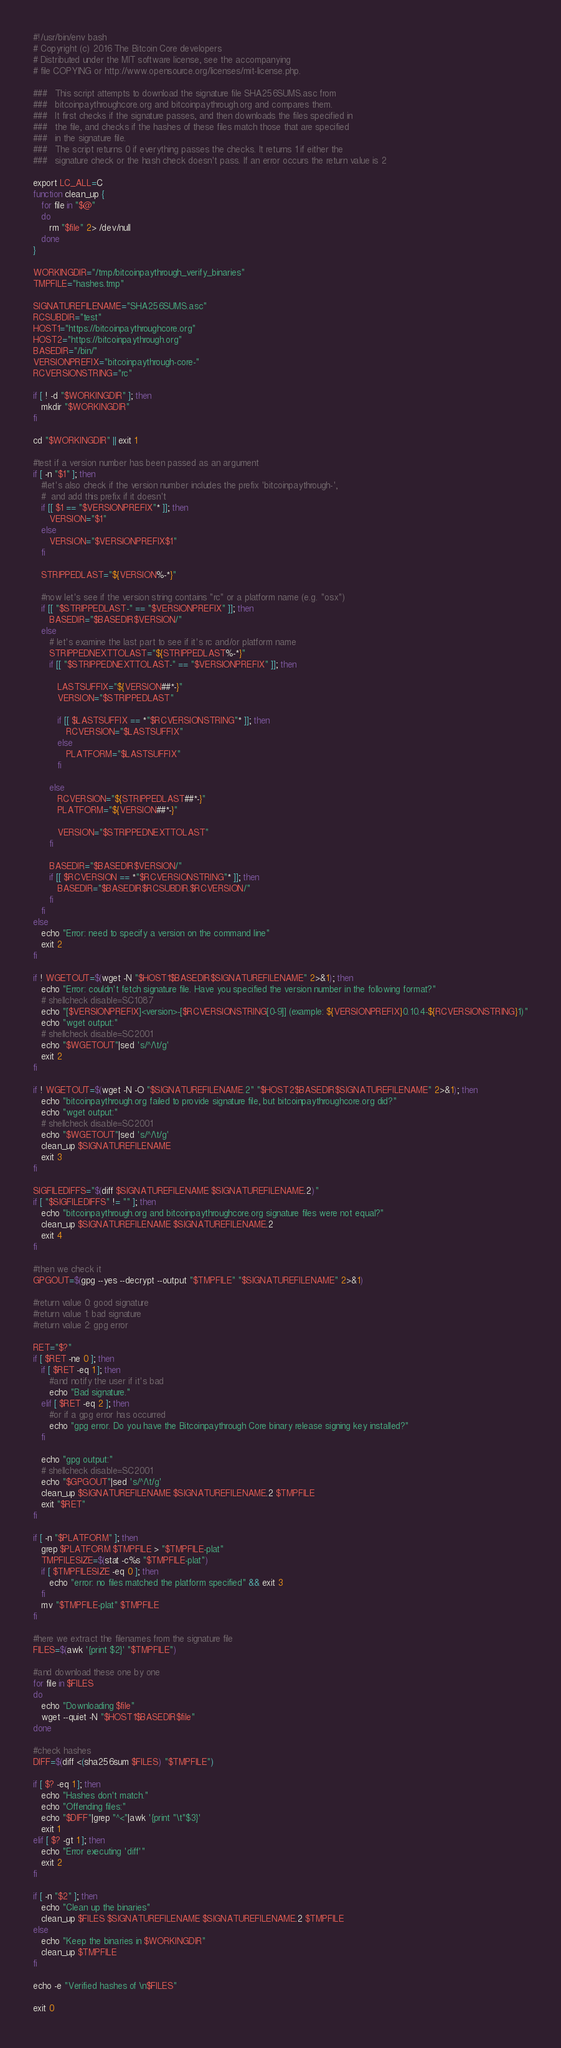<code> <loc_0><loc_0><loc_500><loc_500><_Bash_>#!/usr/bin/env bash
# Copyright (c) 2016 The Bitcoin Core developers
# Distributed under the MIT software license, see the accompanying
# file COPYING or http://www.opensource.org/licenses/mit-license.php.

###   This script attempts to download the signature file SHA256SUMS.asc from
###   bitcoinpaythroughcore.org and bitcoinpaythrough.org and compares them.
###   It first checks if the signature passes, and then downloads the files specified in
###   the file, and checks if the hashes of these files match those that are specified
###   in the signature file.
###   The script returns 0 if everything passes the checks. It returns 1 if either the
###   signature check or the hash check doesn't pass. If an error occurs the return value is 2

export LC_ALL=C
function clean_up {
   for file in "$@"
   do
      rm "$file" 2> /dev/null
   done
}

WORKINGDIR="/tmp/bitcoinpaythrough_verify_binaries"
TMPFILE="hashes.tmp"

SIGNATUREFILENAME="SHA256SUMS.asc"
RCSUBDIR="test"
HOST1="https://bitcoinpaythroughcore.org"
HOST2="https://bitcoinpaythrough.org"
BASEDIR="/bin/"
VERSIONPREFIX="bitcoinpaythrough-core-"
RCVERSIONSTRING="rc"

if [ ! -d "$WORKINGDIR" ]; then
   mkdir "$WORKINGDIR"
fi

cd "$WORKINGDIR" || exit 1

#test if a version number has been passed as an argument
if [ -n "$1" ]; then
   #let's also check if the version number includes the prefix 'bitcoinpaythrough-',
   #  and add this prefix if it doesn't
   if [[ $1 == "$VERSIONPREFIX"* ]]; then
      VERSION="$1"
   else
      VERSION="$VERSIONPREFIX$1"
   fi

   STRIPPEDLAST="${VERSION%-*}"

   #now let's see if the version string contains "rc" or a platform name (e.g. "osx")
   if [[ "$STRIPPEDLAST-" == "$VERSIONPREFIX" ]]; then
      BASEDIR="$BASEDIR$VERSION/"
   else
      # let's examine the last part to see if it's rc and/or platform name
      STRIPPEDNEXTTOLAST="${STRIPPEDLAST%-*}"
      if [[ "$STRIPPEDNEXTTOLAST-" == "$VERSIONPREFIX" ]]; then

         LASTSUFFIX="${VERSION##*-}"
         VERSION="$STRIPPEDLAST"

         if [[ $LASTSUFFIX == *"$RCVERSIONSTRING"* ]]; then
            RCVERSION="$LASTSUFFIX"
         else
            PLATFORM="$LASTSUFFIX"
         fi

      else
         RCVERSION="${STRIPPEDLAST##*-}"
         PLATFORM="${VERSION##*-}"

         VERSION="$STRIPPEDNEXTTOLAST"
      fi

      BASEDIR="$BASEDIR$VERSION/"
      if [[ $RCVERSION == *"$RCVERSIONSTRING"* ]]; then
         BASEDIR="$BASEDIR$RCSUBDIR.$RCVERSION/"
      fi
   fi
else
   echo "Error: need to specify a version on the command line"
   exit 2
fi

if ! WGETOUT=$(wget -N "$HOST1$BASEDIR$SIGNATUREFILENAME" 2>&1); then
   echo "Error: couldn't fetch signature file. Have you specified the version number in the following format?"
   # shellcheck disable=SC1087
   echo "[$VERSIONPREFIX]<version>-[$RCVERSIONSTRING[0-9]] (example: ${VERSIONPREFIX}0.10.4-${RCVERSIONSTRING}1)"
   echo "wget output:"
   # shellcheck disable=SC2001
   echo "$WGETOUT"|sed 's/^/\t/g'
   exit 2
fi

if ! WGETOUT=$(wget -N -O "$SIGNATUREFILENAME.2" "$HOST2$BASEDIR$SIGNATUREFILENAME" 2>&1); then
   echo "bitcoinpaythrough.org failed to provide signature file, but bitcoinpaythroughcore.org did?"
   echo "wget output:"
   # shellcheck disable=SC2001
   echo "$WGETOUT"|sed 's/^/\t/g'
   clean_up $SIGNATUREFILENAME
   exit 3
fi

SIGFILEDIFFS="$(diff $SIGNATUREFILENAME $SIGNATUREFILENAME.2)"
if [ "$SIGFILEDIFFS" != "" ]; then
   echo "bitcoinpaythrough.org and bitcoinpaythroughcore.org signature files were not equal?"
   clean_up $SIGNATUREFILENAME $SIGNATUREFILENAME.2
   exit 4
fi

#then we check it
GPGOUT=$(gpg --yes --decrypt --output "$TMPFILE" "$SIGNATUREFILENAME" 2>&1)

#return value 0: good signature
#return value 1: bad signature
#return value 2: gpg error

RET="$?"
if [ $RET -ne 0 ]; then
   if [ $RET -eq 1 ]; then
      #and notify the user if it's bad
      echo "Bad signature."
   elif [ $RET -eq 2 ]; then
      #or if a gpg error has occurred
      echo "gpg error. Do you have the Bitcoinpaythrough Core binary release signing key installed?"
   fi

   echo "gpg output:"
   # shellcheck disable=SC2001
   echo "$GPGOUT"|sed 's/^/\t/g'
   clean_up $SIGNATUREFILENAME $SIGNATUREFILENAME.2 $TMPFILE
   exit "$RET"
fi

if [ -n "$PLATFORM" ]; then
   grep $PLATFORM $TMPFILE > "$TMPFILE-plat"
   TMPFILESIZE=$(stat -c%s "$TMPFILE-plat")
   if [ $TMPFILESIZE -eq 0 ]; then
      echo "error: no files matched the platform specified" && exit 3
   fi
   mv "$TMPFILE-plat" $TMPFILE
fi

#here we extract the filenames from the signature file
FILES=$(awk '{print $2}' "$TMPFILE")

#and download these one by one
for file in $FILES
do
   echo "Downloading $file"
   wget --quiet -N "$HOST1$BASEDIR$file"
done

#check hashes
DIFF=$(diff <(sha256sum $FILES) "$TMPFILE")

if [ $? -eq 1 ]; then
   echo "Hashes don't match."
   echo "Offending files:"
   echo "$DIFF"|grep "^<"|awk '{print "\t"$3}'
   exit 1
elif [ $? -gt 1 ]; then
   echo "Error executing 'diff'"
   exit 2
fi

if [ -n "$2" ]; then
   echo "Clean up the binaries"
   clean_up $FILES $SIGNATUREFILENAME $SIGNATUREFILENAME.2 $TMPFILE
else
   echo "Keep the binaries in $WORKINGDIR"
   clean_up $TMPFILE
fi

echo -e "Verified hashes of \n$FILES"

exit 0
</code> 